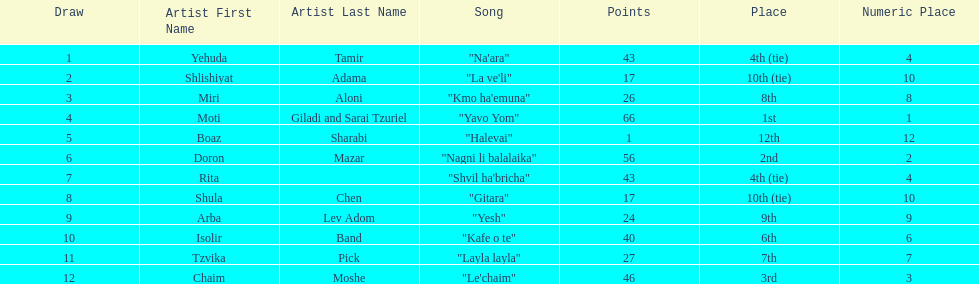Compare draws, which had the least amount of points? Boaz Sharabi. 